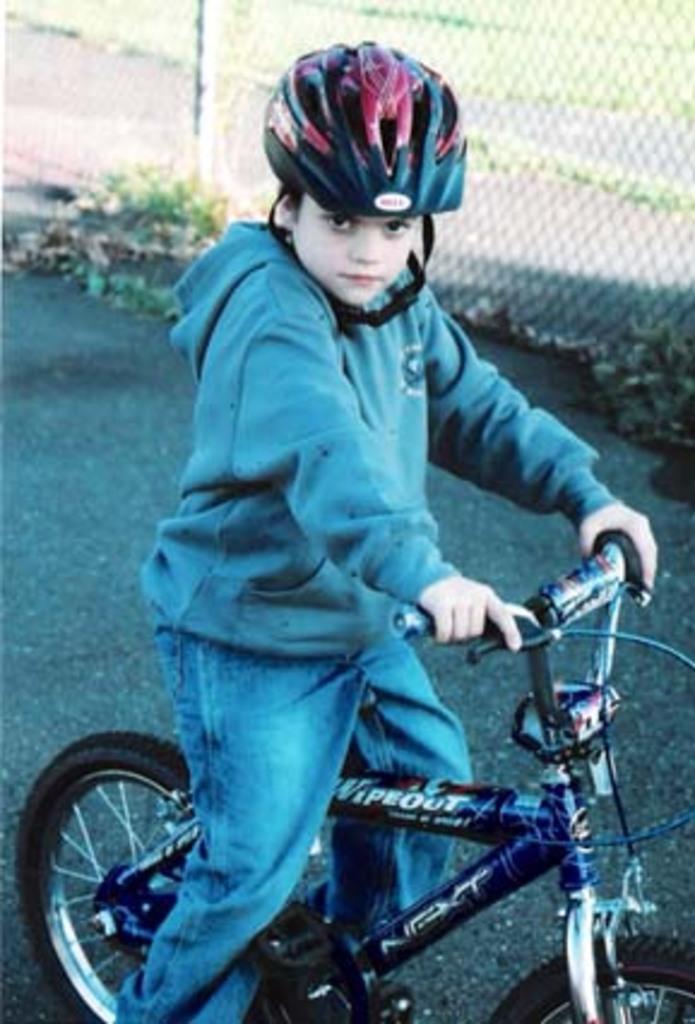In one or two sentences, can you explain what this image depicts? This image consist of a boy sitting on a bicycle, and wearing helmet. He is wearing a blue color jacket and blue pant. The cycle is also in blue color. In the background, there is fencing. At the bottom, there is road. 